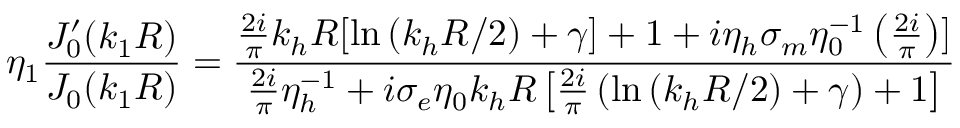Convert formula to latex. <formula><loc_0><loc_0><loc_500><loc_500>\eta _ { 1 } \frac { J _ { 0 } ^ { \prime } ( k _ { 1 } R ) } { J _ { 0 } ( k _ { 1 } R ) } = \frac { \frac { 2 i } { \pi } k _ { h } R [ \ln { ( k _ { h } R / 2 ) + \gamma ] + 1 + i \eta _ { h } \sigma _ { m } \eta _ { 0 } ^ { - 1 } \left ( \frac { 2 i } { \pi } \right ) } ] } { \frac { 2 i } { \pi } \eta _ { h } ^ { - 1 } + i \sigma _ { e } \eta _ { 0 } k _ { h } R \left [ \frac { 2 i } { \pi } \left ( \ln { ( k _ { h } R / 2 ) + \gamma } \right ) + 1 \right ] }</formula> 